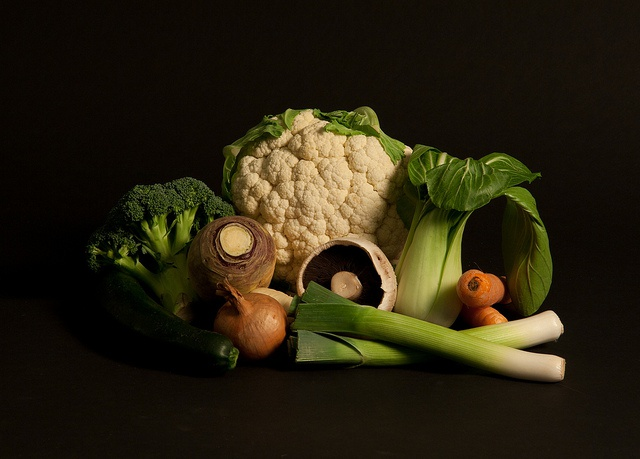Describe the objects in this image and their specific colors. I can see broccoli in black, darkgreen, and olive tones, carrot in black, brown, maroon, and red tones, and carrot in black, maroon, red, and orange tones in this image. 